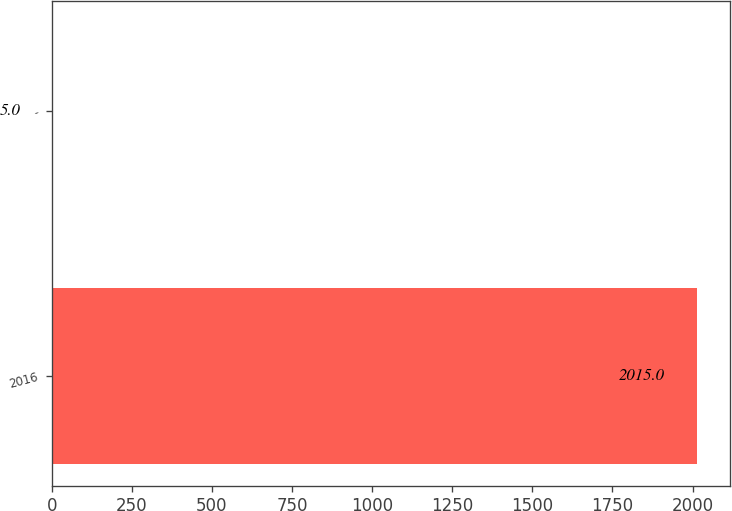Convert chart to OTSL. <chart><loc_0><loc_0><loc_500><loc_500><bar_chart><fcel>2016<fcel>-<nl><fcel>2015<fcel>5<nl></chart> 